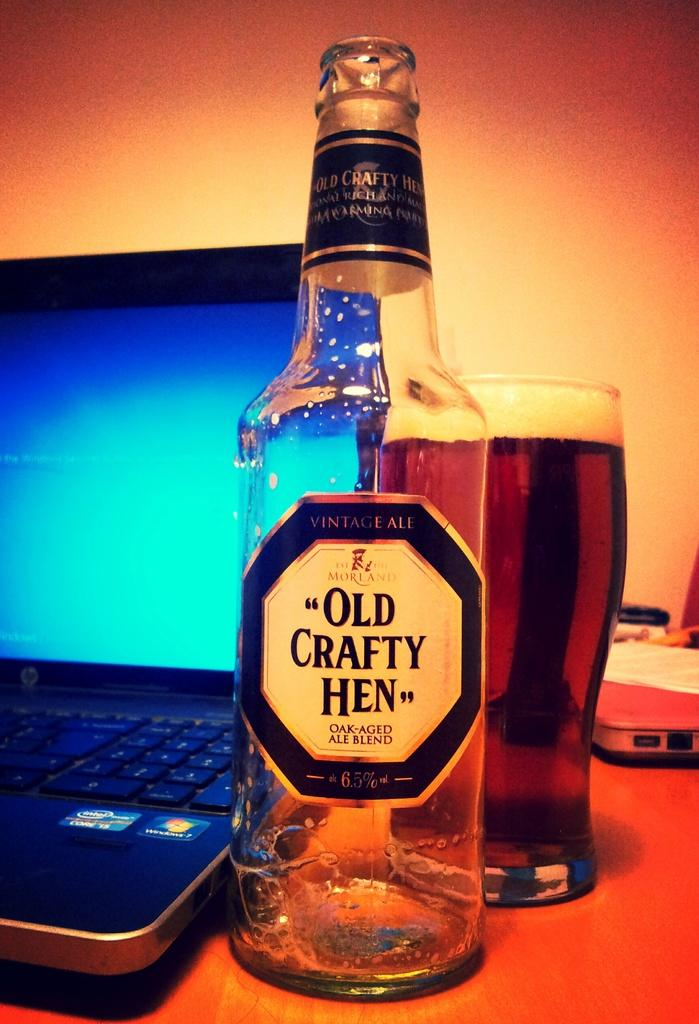<image>
Provide a brief description of the given image. a glass bottle that is called the Old Crafty Hen 